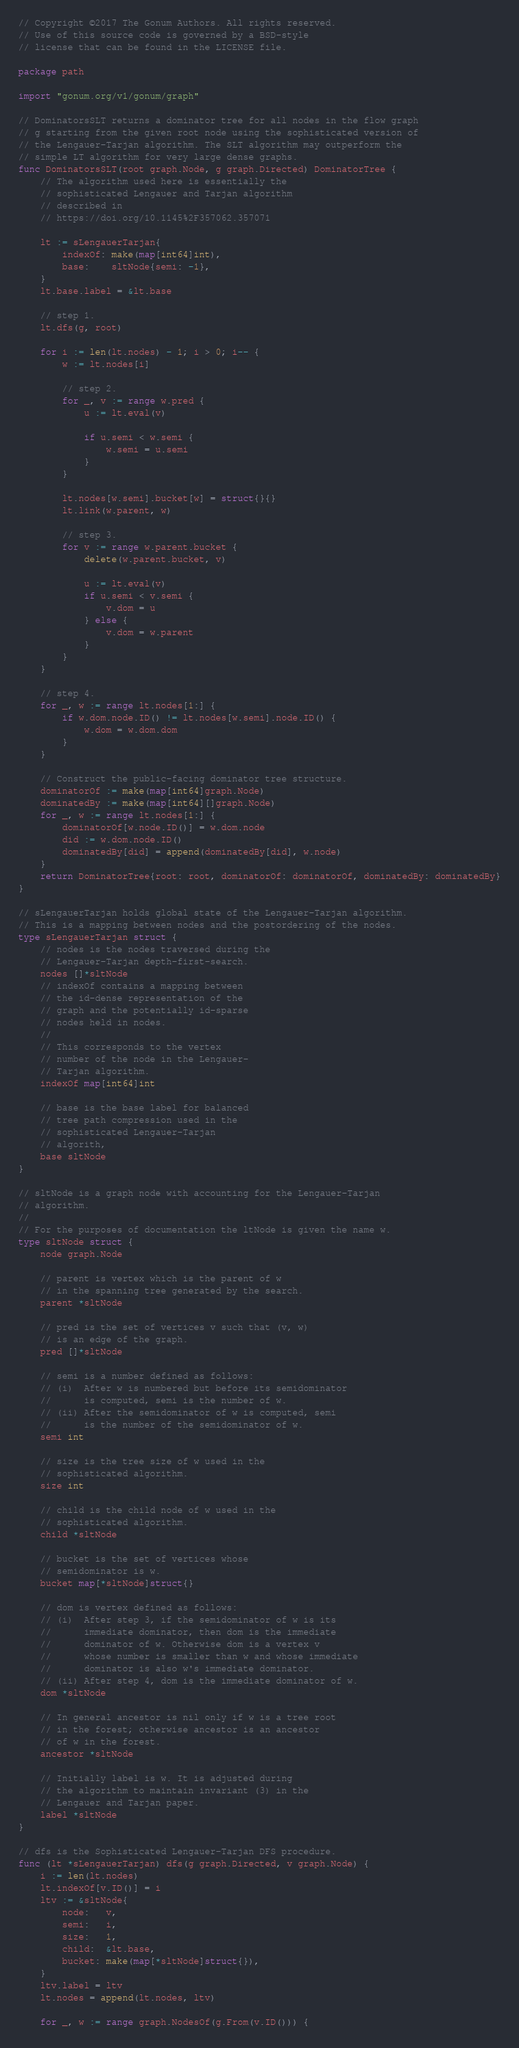Convert code to text. <code><loc_0><loc_0><loc_500><loc_500><_Go_>// Copyright ©2017 The Gonum Authors. All rights reserved.
// Use of this source code is governed by a BSD-style
// license that can be found in the LICENSE file.

package path

import "gonum.org/v1/gonum/graph"

// DominatorsSLT returns a dominator tree for all nodes in the flow graph
// g starting from the given root node using the sophisticated version of
// the Lengauer-Tarjan algorithm. The SLT algorithm may outperform the
// simple LT algorithm for very large dense graphs.
func DominatorsSLT(root graph.Node, g graph.Directed) DominatorTree {
	// The algorithm used here is essentially the
	// sophisticated Lengauer and Tarjan algorithm
	// described in
	// https://doi.org/10.1145%2F357062.357071

	lt := sLengauerTarjan{
		indexOf: make(map[int64]int),
		base:    sltNode{semi: -1},
	}
	lt.base.label = &lt.base

	// step 1.
	lt.dfs(g, root)

	for i := len(lt.nodes) - 1; i > 0; i-- {
		w := lt.nodes[i]

		// step 2.
		for _, v := range w.pred {
			u := lt.eval(v)

			if u.semi < w.semi {
				w.semi = u.semi
			}
		}

		lt.nodes[w.semi].bucket[w] = struct{}{}
		lt.link(w.parent, w)

		// step 3.
		for v := range w.parent.bucket {
			delete(w.parent.bucket, v)

			u := lt.eval(v)
			if u.semi < v.semi {
				v.dom = u
			} else {
				v.dom = w.parent
			}
		}
	}

	// step 4.
	for _, w := range lt.nodes[1:] {
		if w.dom.node.ID() != lt.nodes[w.semi].node.ID() {
			w.dom = w.dom.dom
		}
	}

	// Construct the public-facing dominator tree structure.
	dominatorOf := make(map[int64]graph.Node)
	dominatedBy := make(map[int64][]graph.Node)
	for _, w := range lt.nodes[1:] {
		dominatorOf[w.node.ID()] = w.dom.node
		did := w.dom.node.ID()
		dominatedBy[did] = append(dominatedBy[did], w.node)
	}
	return DominatorTree{root: root, dominatorOf: dominatorOf, dominatedBy: dominatedBy}
}

// sLengauerTarjan holds global state of the Lengauer-Tarjan algorithm.
// This is a mapping between nodes and the postordering of the nodes.
type sLengauerTarjan struct {
	// nodes is the nodes traversed during the
	// Lengauer-Tarjan depth-first-search.
	nodes []*sltNode
	// indexOf contains a mapping between
	// the id-dense representation of the
	// graph and the potentially id-sparse
	// nodes held in nodes.
	//
	// This corresponds to the vertex
	// number of the node in the Lengauer-
	// Tarjan algorithm.
	indexOf map[int64]int

	// base is the base label for balanced
	// tree path compression used in the
	// sophisticated Lengauer-Tarjan
	// algorith,
	base sltNode
}

// sltNode is a graph node with accounting for the Lengauer-Tarjan
// algorithm.
//
// For the purposes of documentation the ltNode is given the name w.
type sltNode struct {
	node graph.Node

	// parent is vertex which is the parent of w
	// in the spanning tree generated by the search.
	parent *sltNode

	// pred is the set of vertices v such that (v, w)
	// is an edge of the graph.
	pred []*sltNode

	// semi is a number defined as follows:
	// (i)  After w is numbered but before its semidominator
	//      is computed, semi is the number of w.
	// (ii) After the semidominator of w is computed, semi
	//      is the number of the semidominator of w.
	semi int

	// size is the tree size of w used in the
	// sophisticated algorithm.
	size int

	// child is the child node of w used in the
	// sophisticated algorithm.
	child *sltNode

	// bucket is the set of vertices whose
	// semidominator is w.
	bucket map[*sltNode]struct{}

	// dom is vertex defined as follows:
	// (i)  After step 3, if the semidominator of w is its
	//      immediate dominator, then dom is the immediate
	//      dominator of w. Otherwise dom is a vertex v
	//      whose number is smaller than w and whose immediate
	//      dominator is also w's immediate dominator.
	// (ii) After step 4, dom is the immediate dominator of w.
	dom *sltNode

	// In general ancestor is nil only if w is a tree root
	// in the forest; otherwise ancestor is an ancestor
	// of w in the forest.
	ancestor *sltNode

	// Initially label is w. It is adjusted during
	// the algorithm to maintain invariant (3) in the
	// Lengauer and Tarjan paper.
	label *sltNode
}

// dfs is the Sophisticated Lengauer-Tarjan DFS procedure.
func (lt *sLengauerTarjan) dfs(g graph.Directed, v graph.Node) {
	i := len(lt.nodes)
	lt.indexOf[v.ID()] = i
	ltv := &sltNode{
		node:   v,
		semi:   i,
		size:   1,
		child:  &lt.base,
		bucket: make(map[*sltNode]struct{}),
	}
	ltv.label = ltv
	lt.nodes = append(lt.nodes, ltv)

	for _, w := range graph.NodesOf(g.From(v.ID())) {</code> 